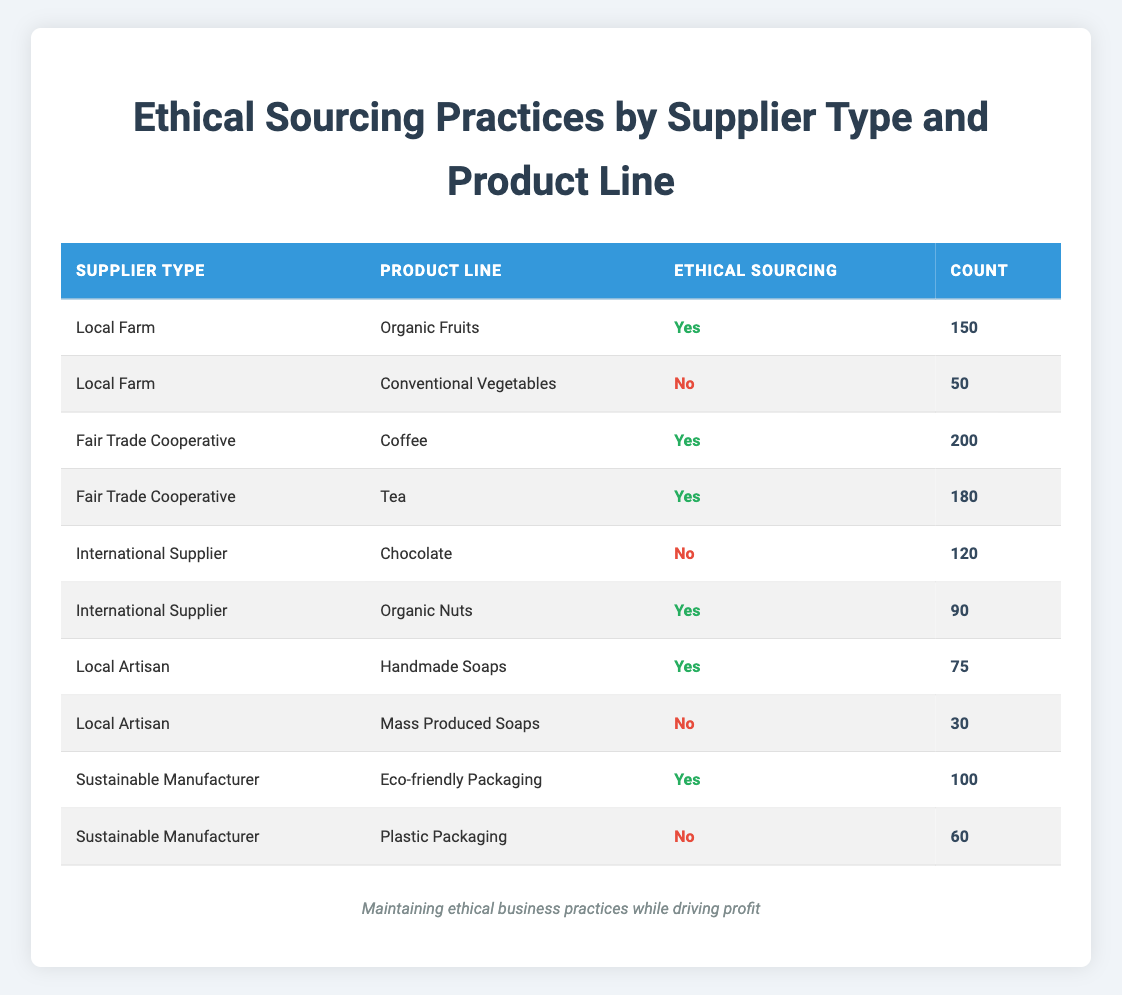What is the count of ethical sourcing practices by Fair Trade Cooperative for Coffee? The table lists a row for Fair Trade Cooperative and Coffee under Ethical Sourcing, which has a count of 200.
Answer: 200 What percentage of the products from Local Farms are ethically sourced? There are 2 products from Local Farms: Organic Fruits (Count 150, Ethical Yes) and Conventional Vegetables (Count 50, Ethical No). The total count is 200, and the count of ethically sourced products is 150. The percentage is calculated as (150/200) * 100 = 75%.
Answer: 75% How many total products are sourced ethically from International Suppliers? There are 2 products from International Suppliers: Chocolate (Count 120, Ethical No) and Organic Nuts (Count 90, Ethical Yes). The total count of ethically sourced products from International Suppliers is just the count of Organic Nuts, which is 90.
Answer: 90 Is there any product from Local Artisan that is not ethically sourced? The table shows that Local Artisan has 2 products: Handmade Soaps (Count 75, Ethical Yes) and Mass Produced Soaps (Count 30, Ethical No). So there is one product (Mass Produced Soaps) that is not ethically sourced.
Answer: Yes What is the total count of ethically sourced products across all supplier types? To find the total count of ethically sourced products, we can sum the counts of "Yes" across all rows: 150 (Local Farm) + 200 (Fair Trade Coffee) + 180 (Fair Trade Tea) + 90 (Organic Nuts) + 75 (Handmade Soaps) + 100 (Eco-friendly Packaging) = 895.
Answer: 895 How many more products are sourced ethically by Fair Trade Cooperatives compared to Local Farms? Fair Trade Cooperatives have 200 (Coffee) + 180 (Tea) = 380 ethically sourced products. Local Farms have 150 (Organic Fruits) = 150. The difference is 380 - 150 = 230.
Answer: 230 What is the count of products that are not ethically sourced under Sustainable Manufacturer? According to the table, under Sustainable Manufacturer, there is one product that is not ethically sourced, which is Plastic Packaging with a count of 60.
Answer: 60 Which supplier type has the highest count of ethically sourced products? Looking at the counts of ethically sourced products: Fair Trade Cooperative has 380, Local Farm has 150, International Supplier has 90, Local Artisan has 75, and Sustainable Manufacturer has 100. The highest is 380 from Fair Trade Cooperative.
Answer: Fair Trade Cooperative 